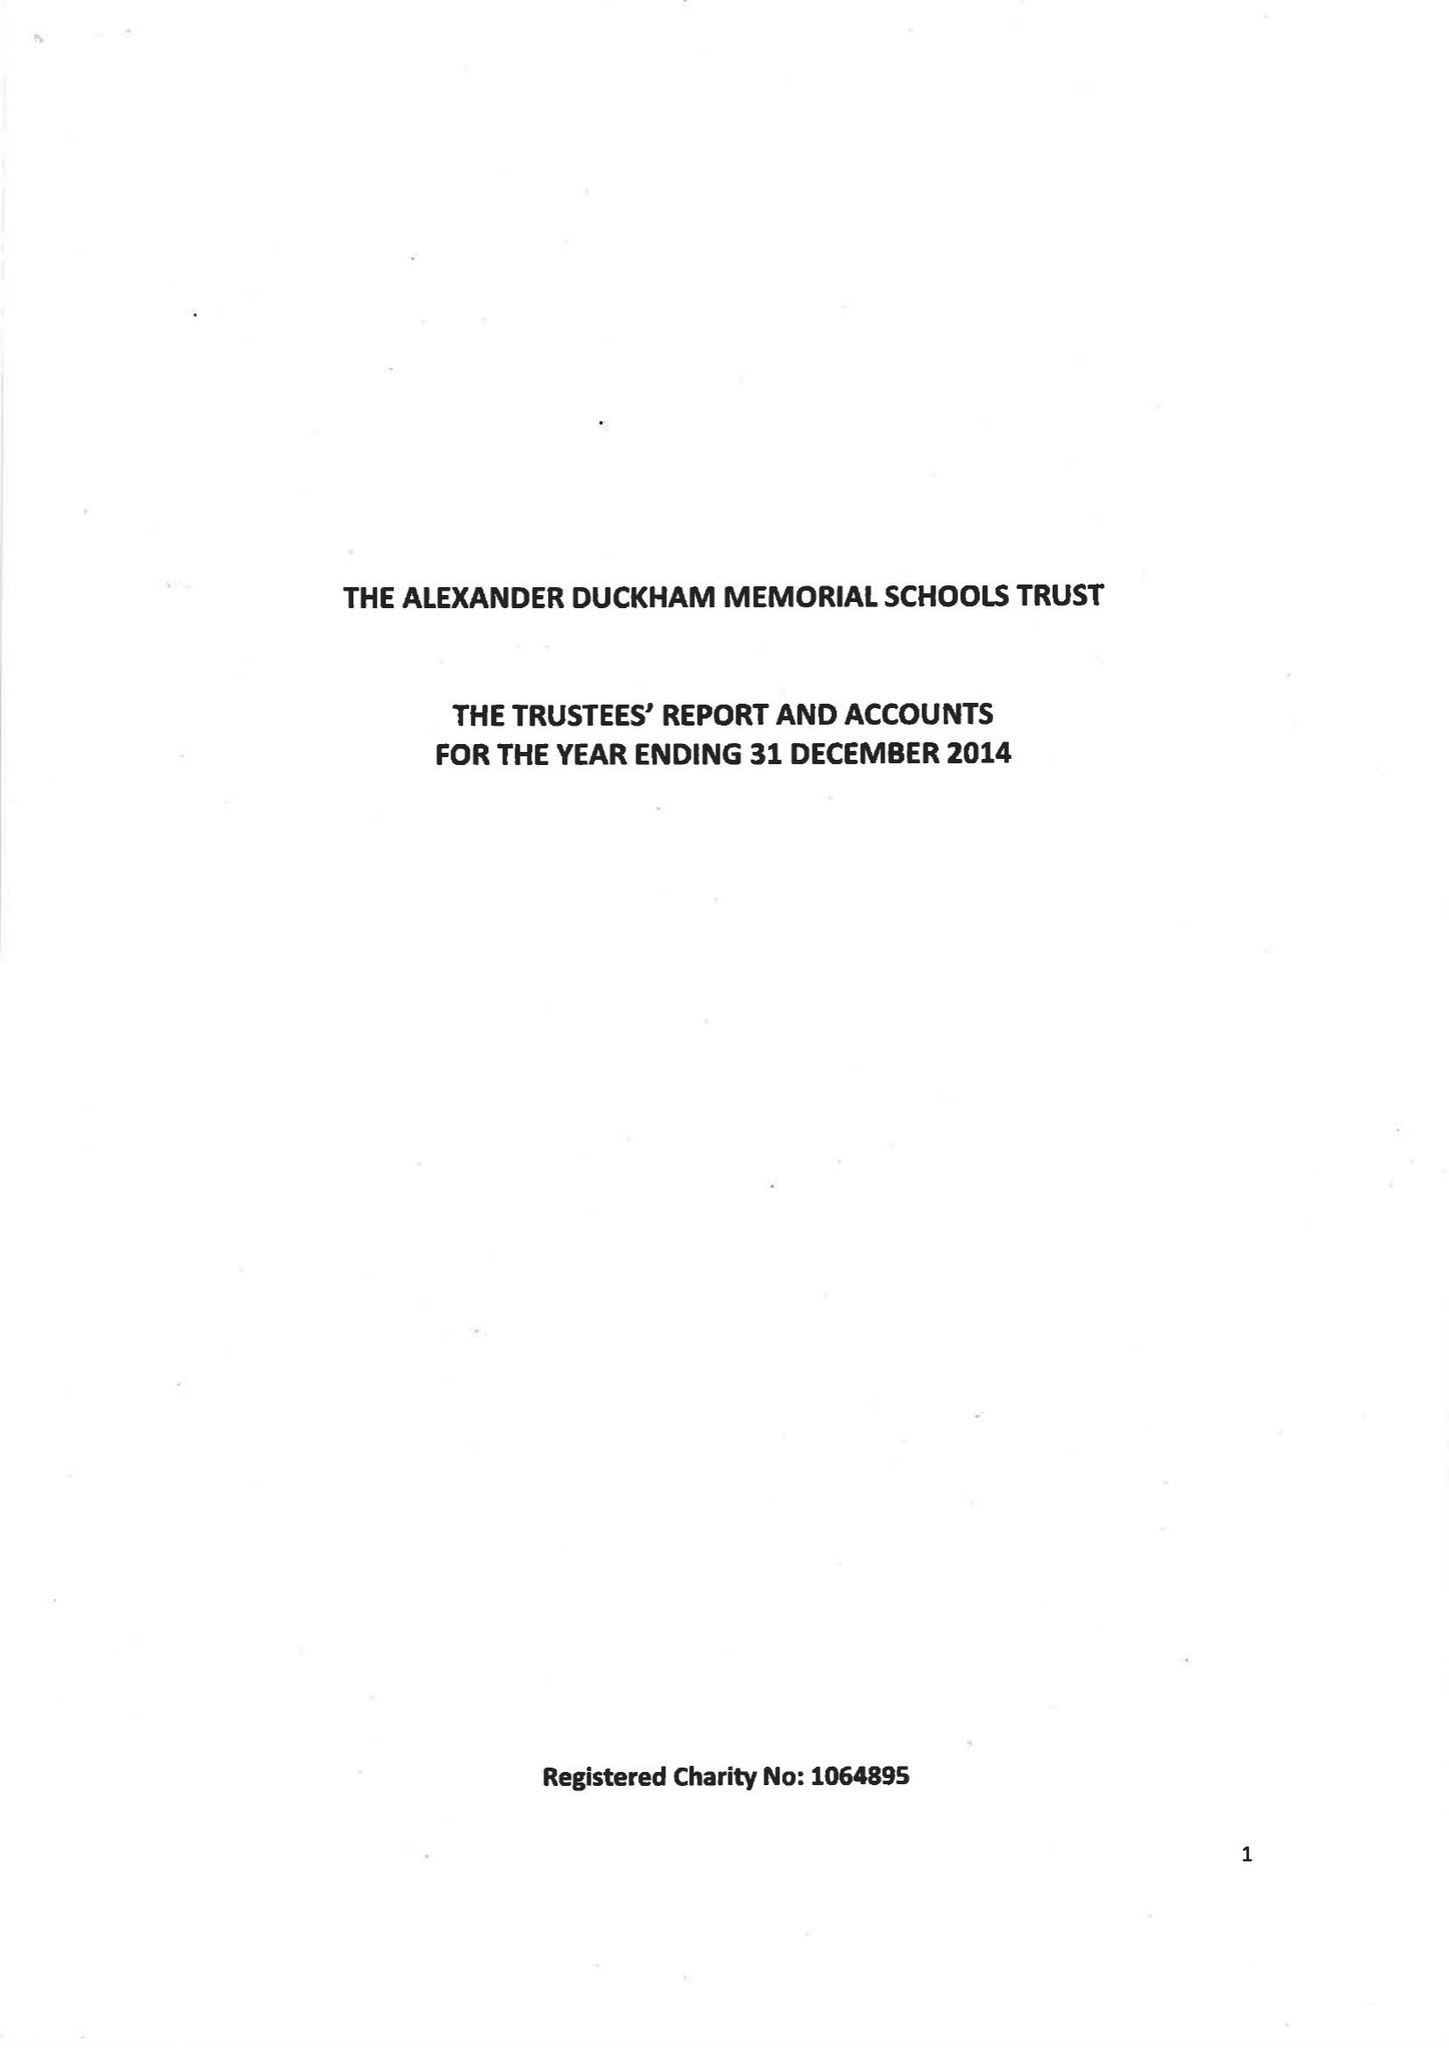What is the value for the report_date?
Answer the question using a single word or phrase. 2015-12-31 